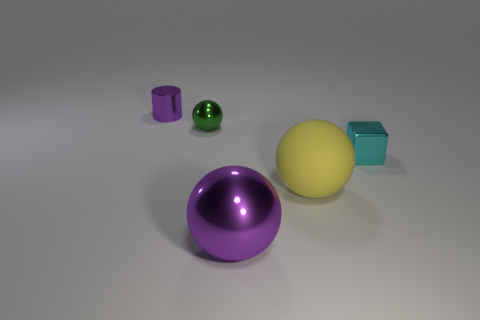Add 1 tiny metal blocks. How many objects exist? 6 Subtract all blocks. How many objects are left? 4 Subtract all gray metallic cylinders. Subtract all small green shiny things. How many objects are left? 4 Add 2 green spheres. How many green spheres are left? 3 Add 3 cyan matte cylinders. How many cyan matte cylinders exist? 3 Subtract 1 purple balls. How many objects are left? 4 